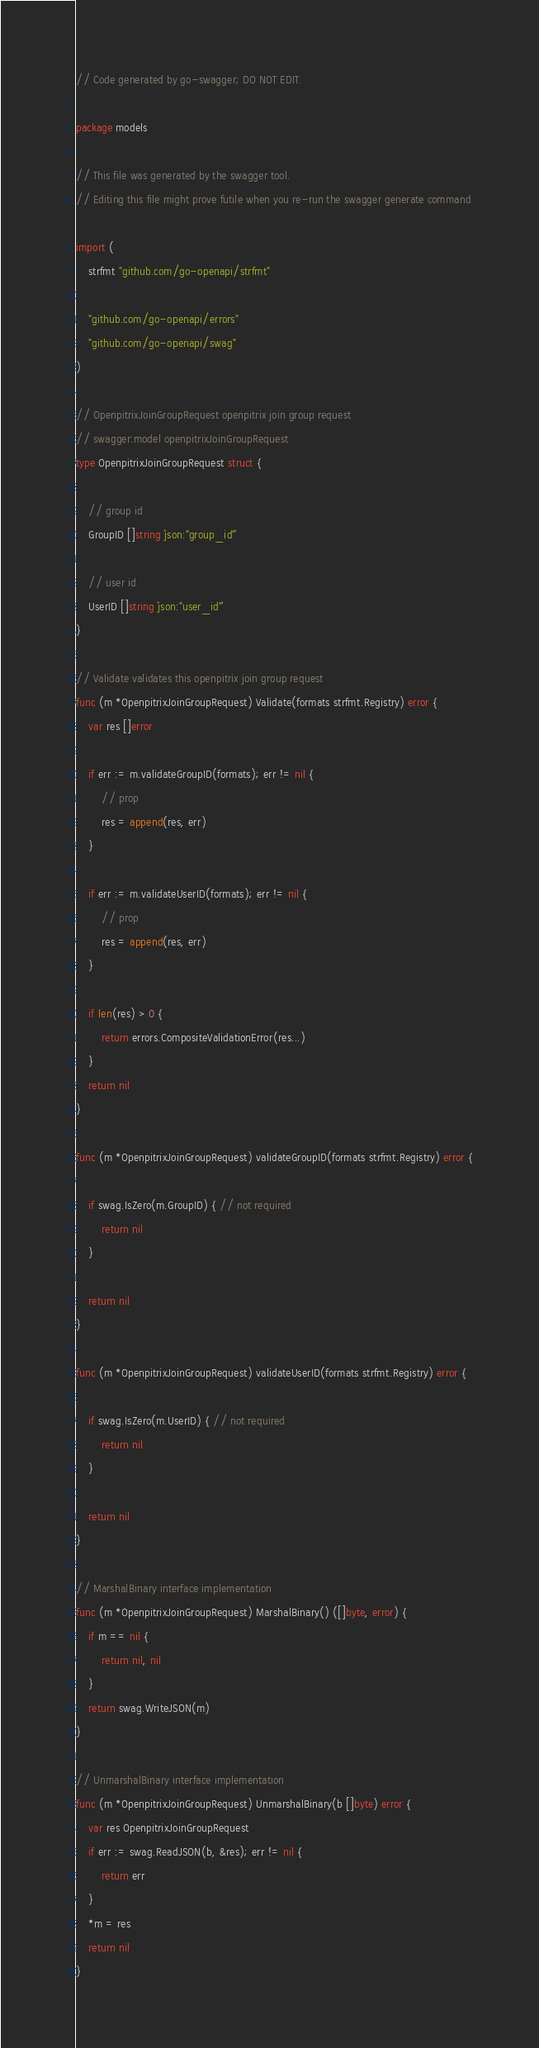Convert code to text. <code><loc_0><loc_0><loc_500><loc_500><_Go_>// Code generated by go-swagger; DO NOT EDIT.

package models

// This file was generated by the swagger tool.
// Editing this file might prove futile when you re-run the swagger generate command

import (
	strfmt "github.com/go-openapi/strfmt"

	"github.com/go-openapi/errors"
	"github.com/go-openapi/swag"
)

// OpenpitrixJoinGroupRequest openpitrix join group request
// swagger:model openpitrixJoinGroupRequest
type OpenpitrixJoinGroupRequest struct {

	// group id
	GroupID []string `json:"group_id"`

	// user id
	UserID []string `json:"user_id"`
}

// Validate validates this openpitrix join group request
func (m *OpenpitrixJoinGroupRequest) Validate(formats strfmt.Registry) error {
	var res []error

	if err := m.validateGroupID(formats); err != nil {
		// prop
		res = append(res, err)
	}

	if err := m.validateUserID(formats); err != nil {
		// prop
		res = append(res, err)
	}

	if len(res) > 0 {
		return errors.CompositeValidationError(res...)
	}
	return nil
}

func (m *OpenpitrixJoinGroupRequest) validateGroupID(formats strfmt.Registry) error {

	if swag.IsZero(m.GroupID) { // not required
		return nil
	}

	return nil
}

func (m *OpenpitrixJoinGroupRequest) validateUserID(formats strfmt.Registry) error {

	if swag.IsZero(m.UserID) { // not required
		return nil
	}

	return nil
}

// MarshalBinary interface implementation
func (m *OpenpitrixJoinGroupRequest) MarshalBinary() ([]byte, error) {
	if m == nil {
		return nil, nil
	}
	return swag.WriteJSON(m)
}

// UnmarshalBinary interface implementation
func (m *OpenpitrixJoinGroupRequest) UnmarshalBinary(b []byte) error {
	var res OpenpitrixJoinGroupRequest
	if err := swag.ReadJSON(b, &res); err != nil {
		return err
	}
	*m = res
	return nil
}
</code> 